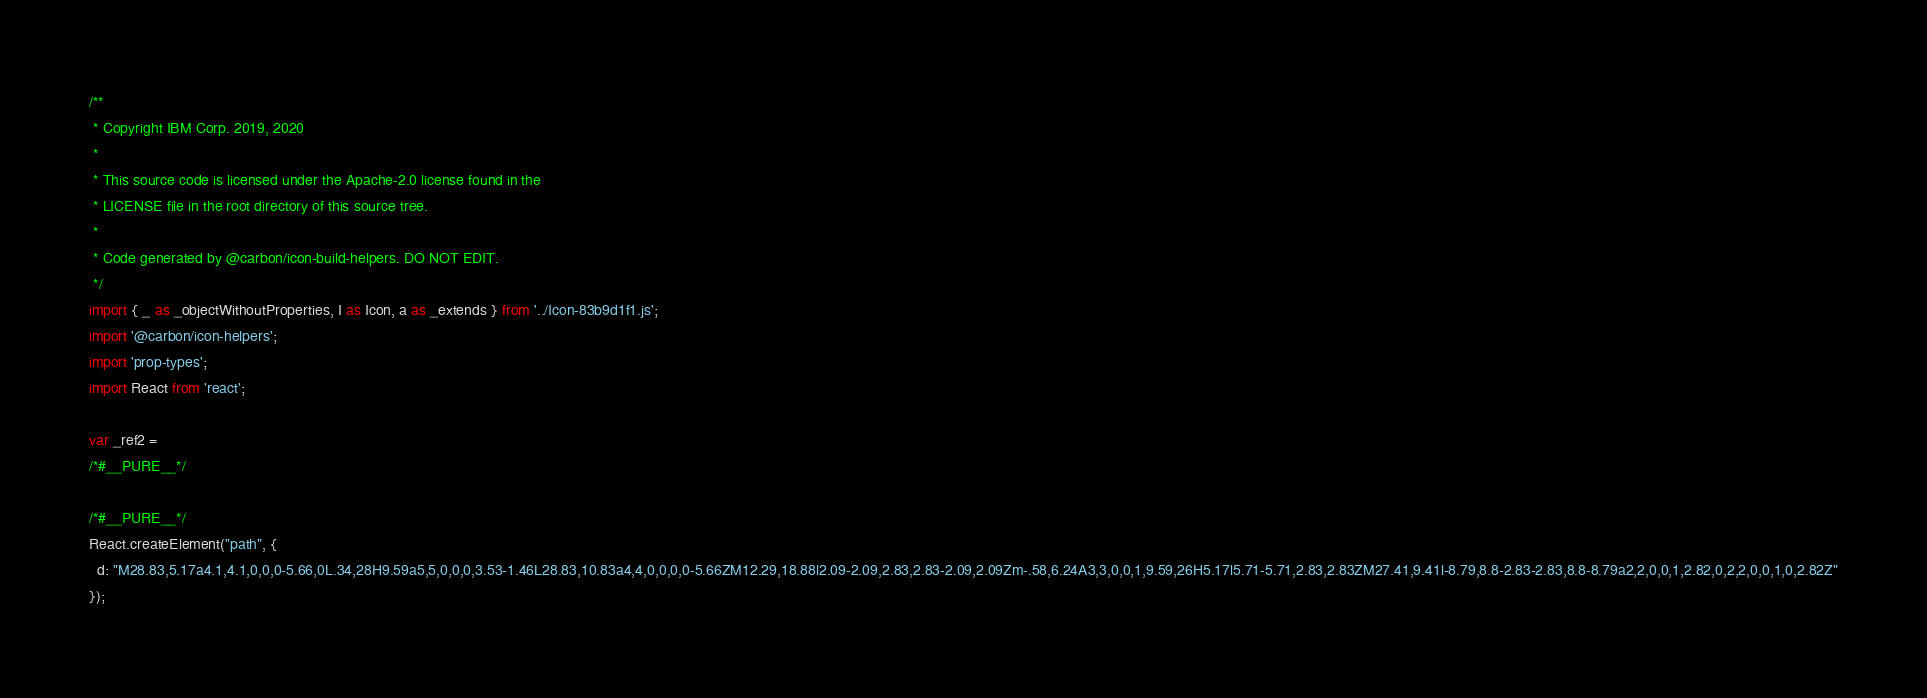<code> <loc_0><loc_0><loc_500><loc_500><_JavaScript_>/**
 * Copyright IBM Corp. 2019, 2020
 *
 * This source code is licensed under the Apache-2.0 license found in the
 * LICENSE file in the root directory of this source tree.
 *
 * Code generated by @carbon/icon-build-helpers. DO NOT EDIT.
 */
import { _ as _objectWithoutProperties, I as Icon, a as _extends } from '../Icon-83b9d1f1.js';
import '@carbon/icon-helpers';
import 'prop-types';
import React from 'react';

var _ref2 =
/*#__PURE__*/

/*#__PURE__*/
React.createElement("path", {
  d: "M28.83,5.17a4.1,4.1,0,0,0-5.66,0L.34,28H9.59a5,5,0,0,0,3.53-1.46L28.83,10.83a4,4,0,0,0,0-5.66ZM12.29,18.88l2.09-2.09,2.83,2.83-2.09,2.09Zm-.58,6.24A3,3,0,0,1,9.59,26H5.17l5.71-5.71,2.83,2.83ZM27.41,9.41l-8.79,8.8-2.83-2.83,8.8-8.79a2,2,0,0,1,2.82,0,2,2,0,0,1,0,2.82Z"
});
</code> 